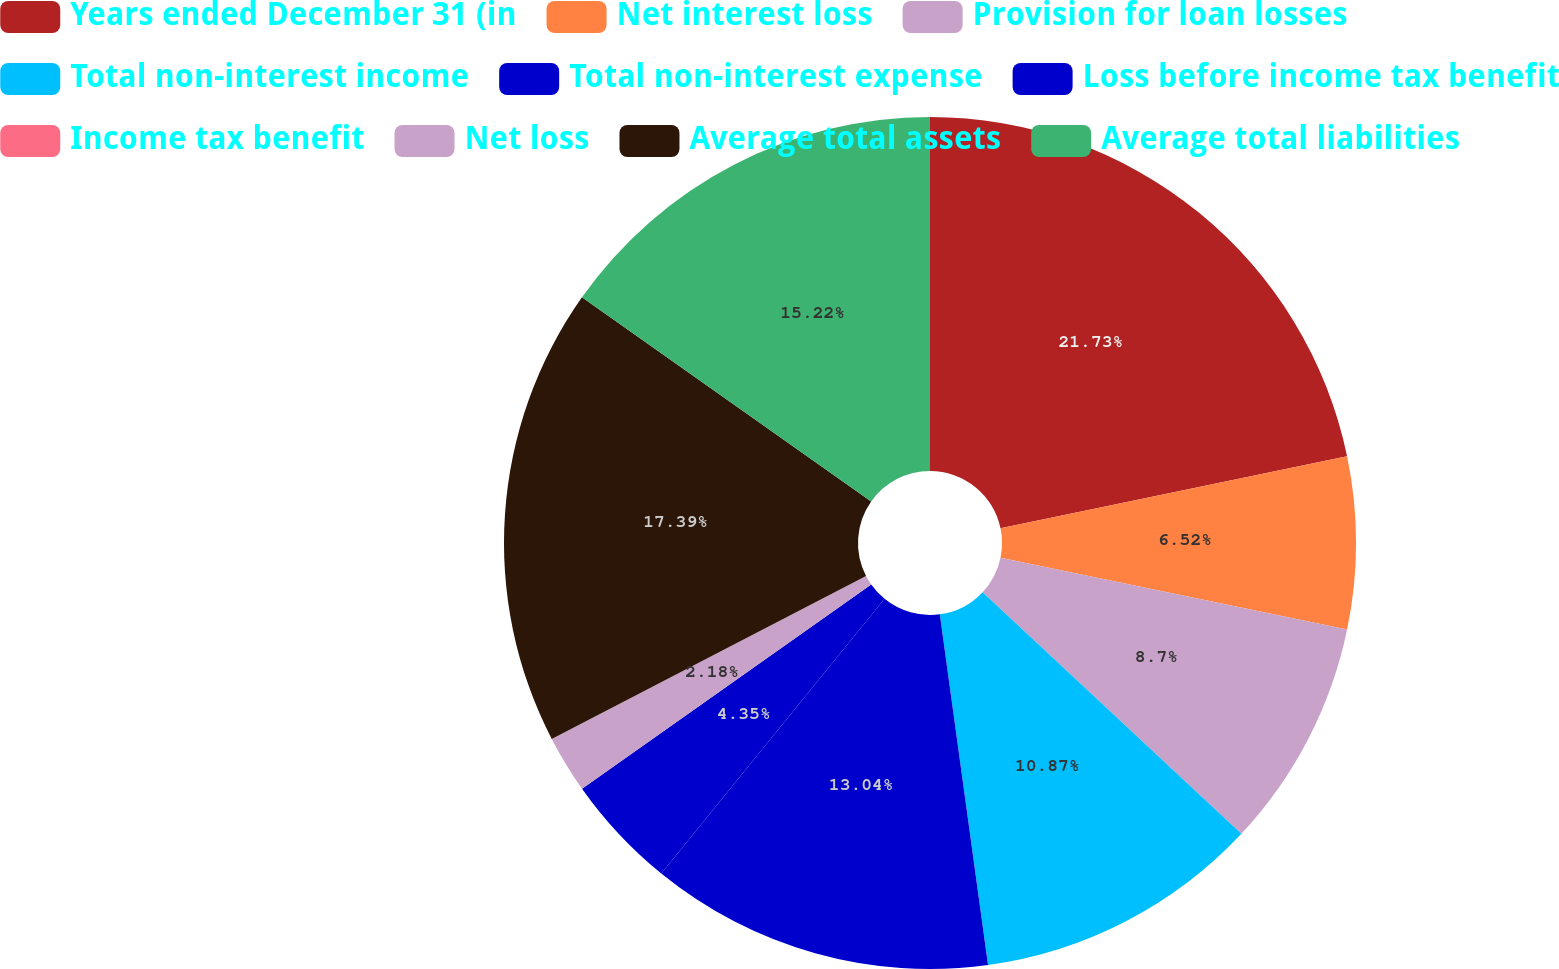<chart> <loc_0><loc_0><loc_500><loc_500><pie_chart><fcel>Years ended December 31 (in<fcel>Net interest loss<fcel>Provision for loan losses<fcel>Total non-interest income<fcel>Total non-interest expense<fcel>Loss before income tax benefit<fcel>Income tax benefit<fcel>Net loss<fcel>Average total assets<fcel>Average total liabilities<nl><fcel>21.74%<fcel>6.52%<fcel>8.7%<fcel>10.87%<fcel>13.04%<fcel>4.35%<fcel>0.0%<fcel>2.18%<fcel>17.39%<fcel>15.22%<nl></chart> 